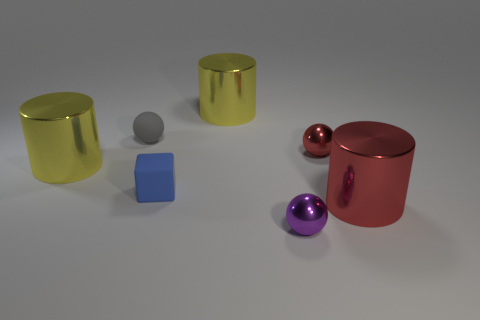Are the blue block and the red cylinder made of the same material?
Ensure brevity in your answer.  No. How many other things are the same color as the tiny matte block?
Ensure brevity in your answer.  0. Are there more big red rubber blocks than rubber balls?
Your answer should be compact. No. There is a block; is it the same size as the shiny thing that is to the left of the matte block?
Provide a short and direct response. No. There is a small metallic object that is in front of the large red shiny cylinder; what color is it?
Make the answer very short. Purple. What number of brown objects are metal cylinders or tiny objects?
Your response must be concise. 0. The small block has what color?
Offer a very short reply. Blue. Are there any other things that have the same material as the tiny red sphere?
Ensure brevity in your answer.  Yes. Is the number of purple spheres on the left side of the tiny matte ball less than the number of metallic cylinders to the left of the small red shiny ball?
Make the answer very short. Yes. There is a thing that is right of the small blue rubber thing and behind the tiny red metal object; what shape is it?
Ensure brevity in your answer.  Cylinder. 